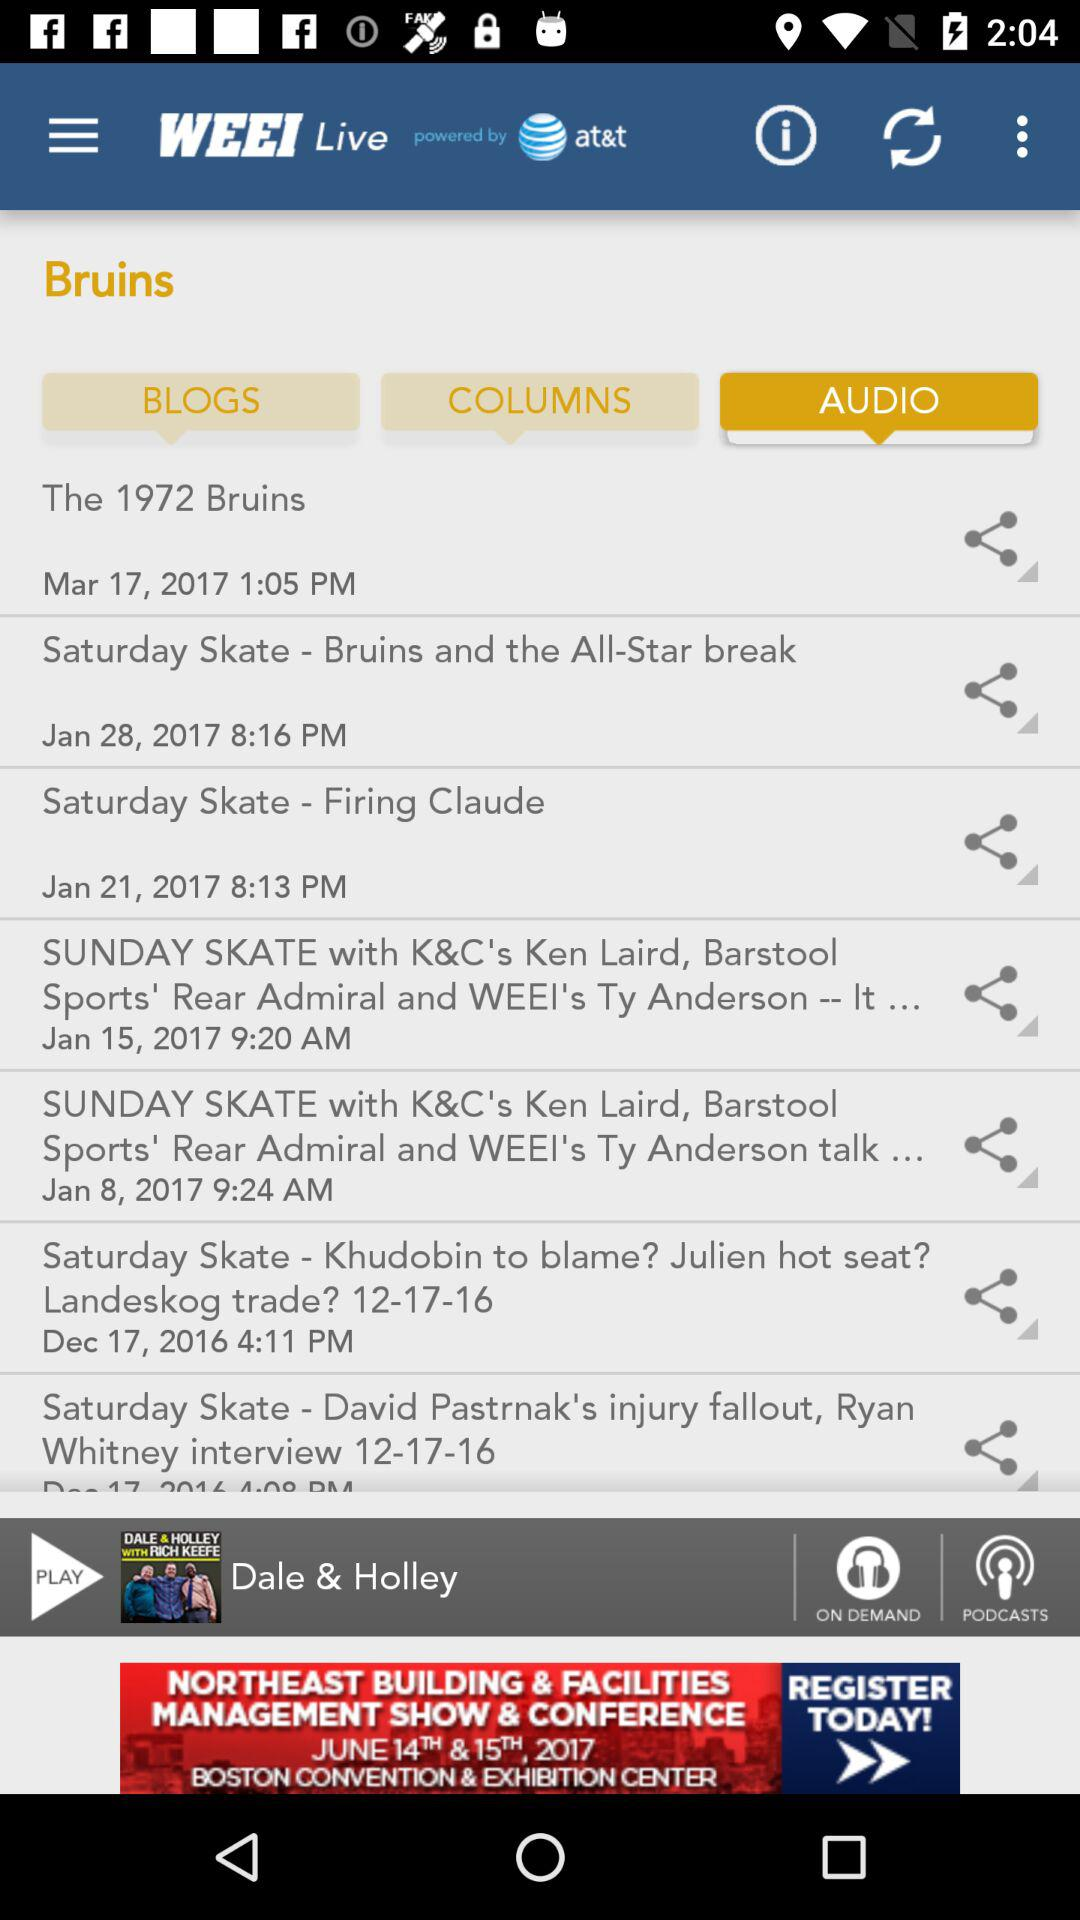What is the name of the application? The name of the application is "WEEI Live". 